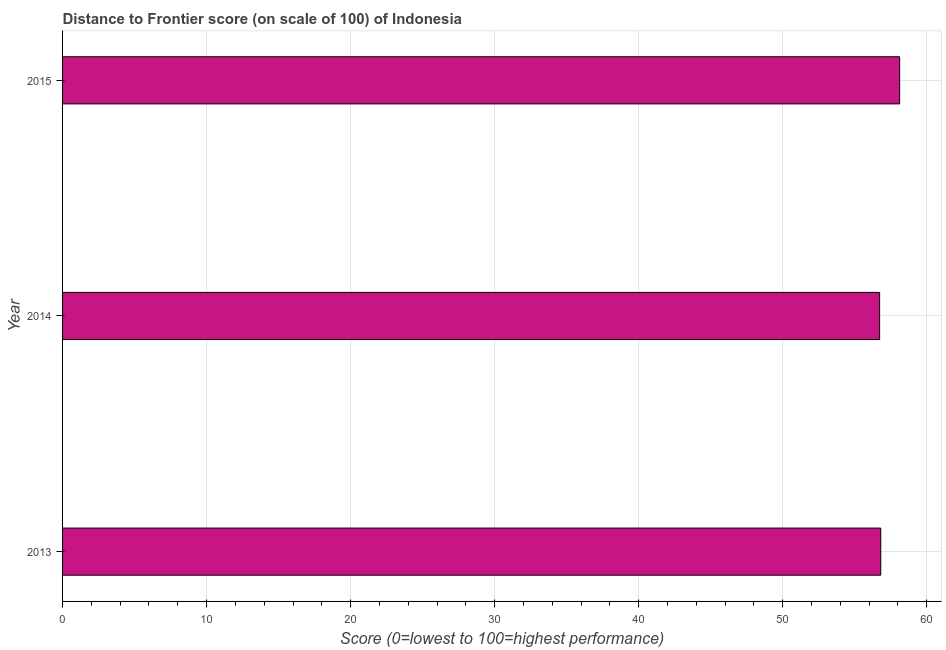Does the graph contain any zero values?
Offer a terse response. No. Does the graph contain grids?
Provide a succinct answer. Yes. What is the title of the graph?
Your response must be concise. Distance to Frontier score (on scale of 100) of Indonesia. What is the label or title of the X-axis?
Keep it short and to the point. Score (0=lowest to 100=highest performance). What is the distance to frontier score in 2013?
Your response must be concise. 56.81. Across all years, what is the maximum distance to frontier score?
Make the answer very short. 58.12. Across all years, what is the minimum distance to frontier score?
Ensure brevity in your answer.  56.73. In which year was the distance to frontier score maximum?
Make the answer very short. 2015. What is the sum of the distance to frontier score?
Provide a short and direct response. 171.66. What is the difference between the distance to frontier score in 2014 and 2015?
Make the answer very short. -1.39. What is the average distance to frontier score per year?
Keep it short and to the point. 57.22. What is the median distance to frontier score?
Your answer should be compact. 56.81. In how many years, is the distance to frontier score greater than 50 ?
Give a very brief answer. 3. Do a majority of the years between 2015 and 2013 (inclusive) have distance to frontier score greater than 4 ?
Your answer should be very brief. Yes. Is the distance to frontier score in 2014 less than that in 2015?
Your response must be concise. Yes. Is the difference between the distance to frontier score in 2013 and 2015 greater than the difference between any two years?
Your answer should be compact. No. What is the difference between the highest and the second highest distance to frontier score?
Offer a very short reply. 1.31. Is the sum of the distance to frontier score in 2013 and 2014 greater than the maximum distance to frontier score across all years?
Provide a short and direct response. Yes. What is the difference between the highest and the lowest distance to frontier score?
Your answer should be very brief. 1.39. Are all the bars in the graph horizontal?
Offer a very short reply. Yes. How many years are there in the graph?
Provide a short and direct response. 3. Are the values on the major ticks of X-axis written in scientific E-notation?
Give a very brief answer. No. What is the Score (0=lowest to 100=highest performance) in 2013?
Your response must be concise. 56.81. What is the Score (0=lowest to 100=highest performance) of 2014?
Offer a terse response. 56.73. What is the Score (0=lowest to 100=highest performance) in 2015?
Your answer should be very brief. 58.12. What is the difference between the Score (0=lowest to 100=highest performance) in 2013 and 2014?
Make the answer very short. 0.08. What is the difference between the Score (0=lowest to 100=highest performance) in 2013 and 2015?
Make the answer very short. -1.31. What is the difference between the Score (0=lowest to 100=highest performance) in 2014 and 2015?
Keep it short and to the point. -1.39. What is the ratio of the Score (0=lowest to 100=highest performance) in 2013 to that in 2015?
Your answer should be compact. 0.98. What is the ratio of the Score (0=lowest to 100=highest performance) in 2014 to that in 2015?
Give a very brief answer. 0.98. 